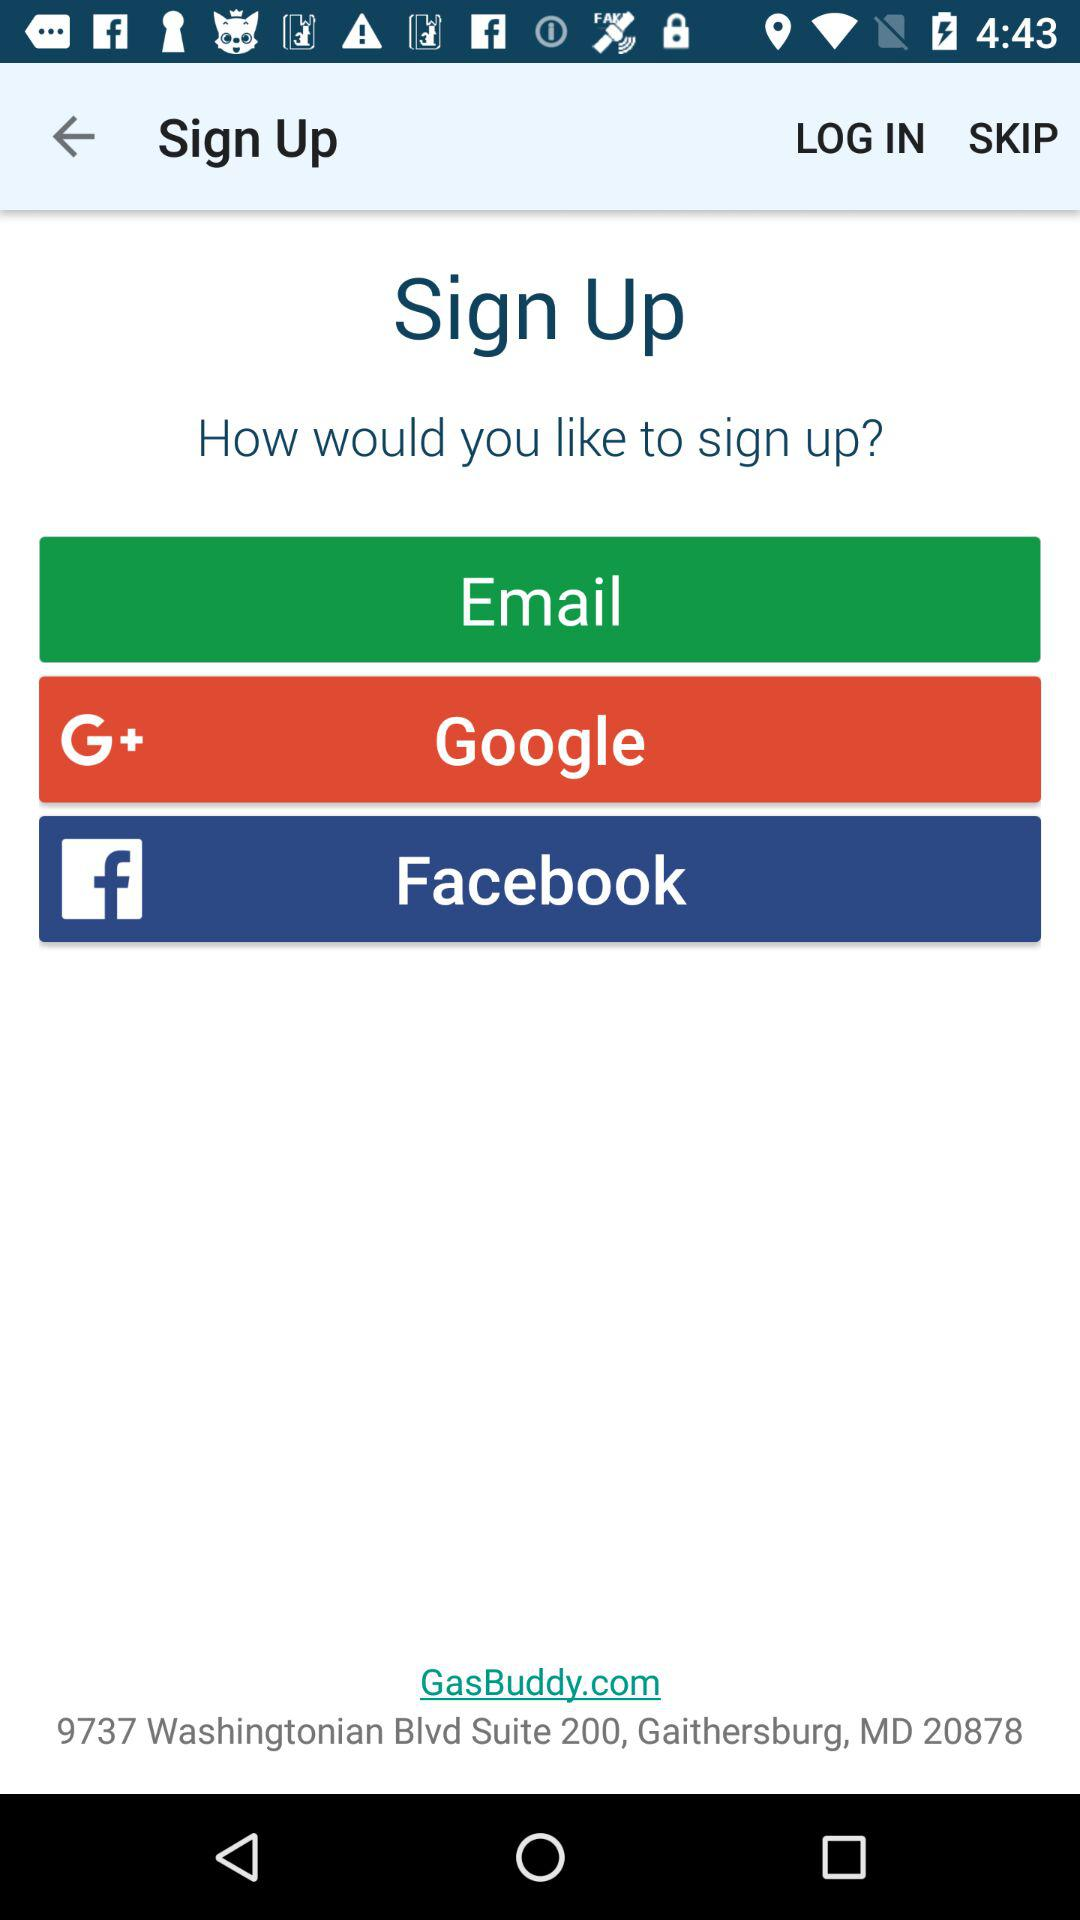How many social media options are there to sign up?
Answer the question using a single word or phrase. 3 